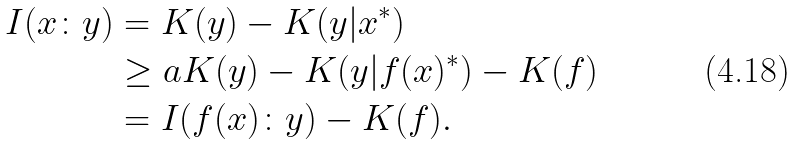Convert formula to latex. <formula><loc_0><loc_0><loc_500><loc_500>I ( x \colon y ) & = K ( y ) - K ( y | x ^ { * } ) \\ & \geq a K ( y ) - K ( y | f ( x ) ^ { * } ) - K ( f ) \\ & = I ( f ( x ) \colon y ) - K ( f ) .</formula> 